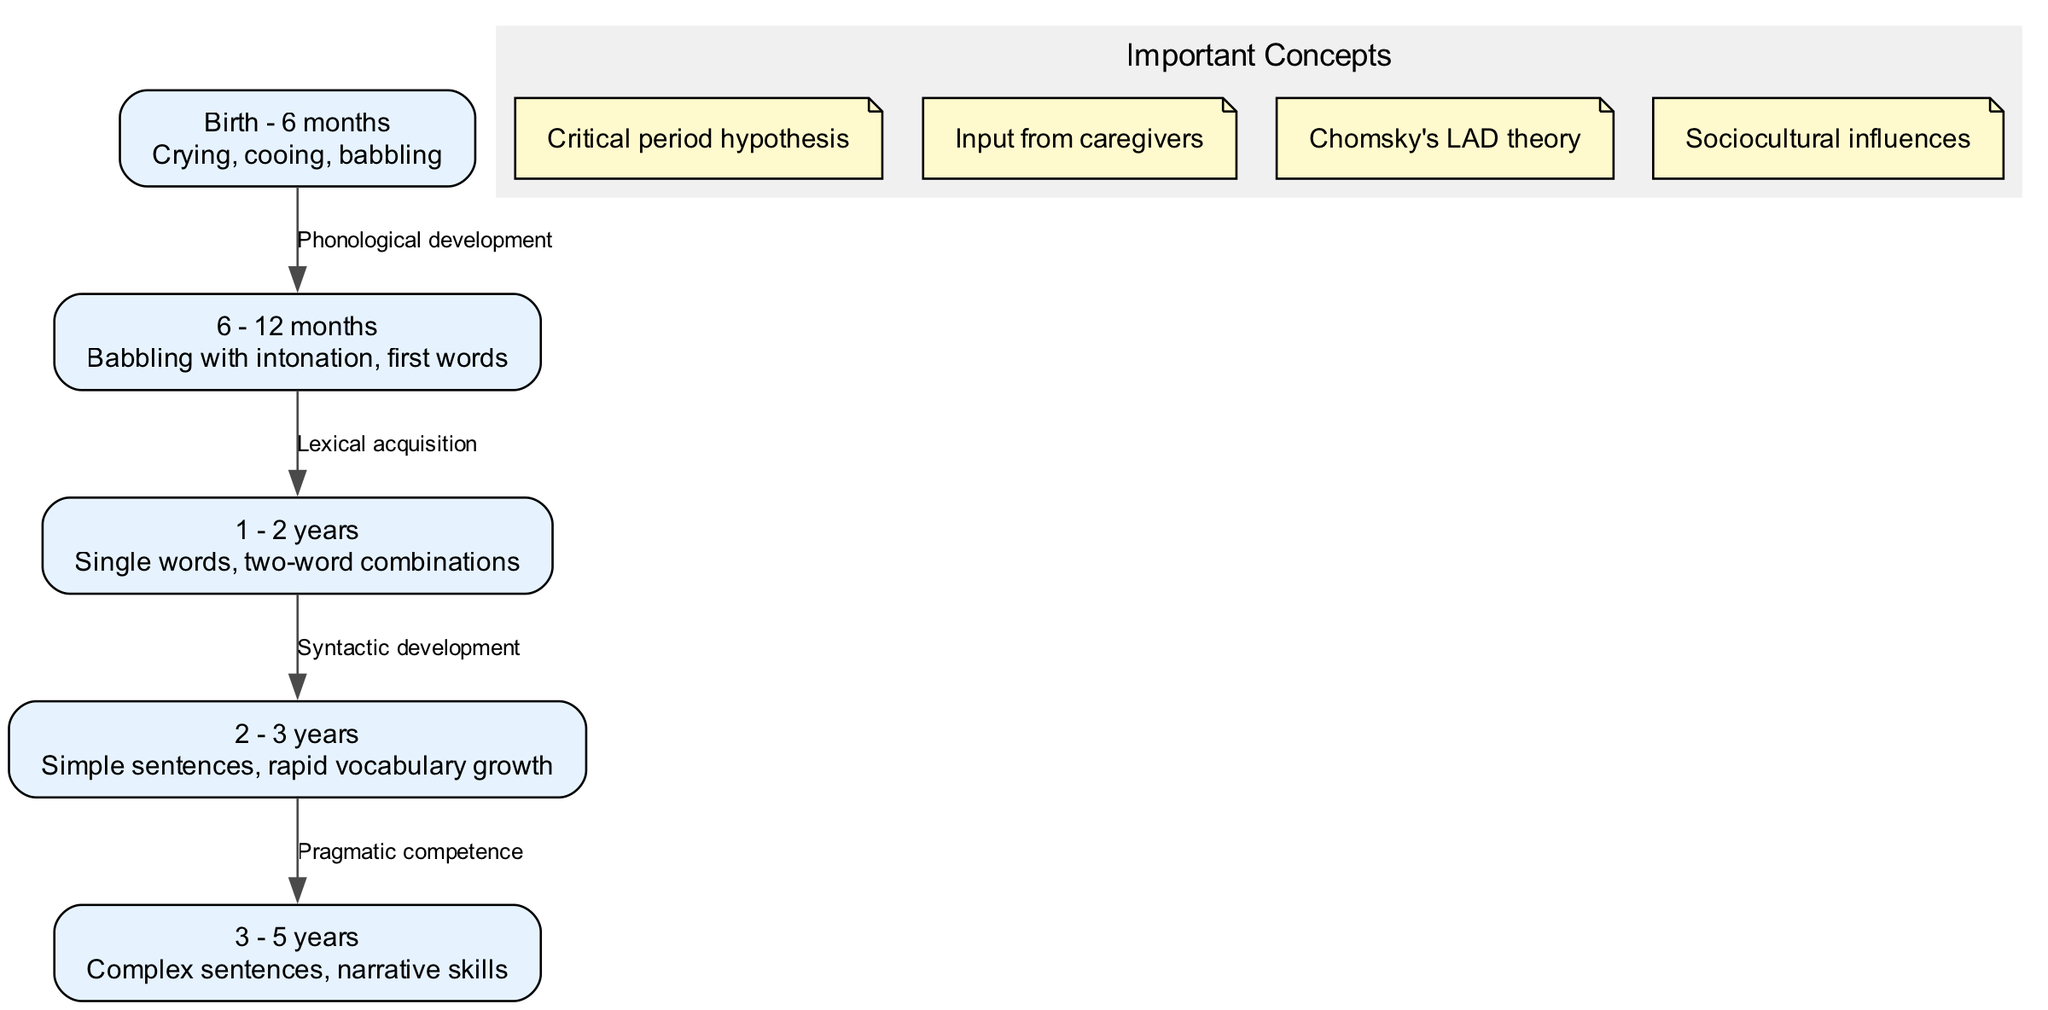What is the age range for the first node in the diagram? The first node is labeled "Birth - 6 months," indicating that this stage represents language acquisition from birth up to six months of age.
Answer: Birth - 6 months How many nodes are there in total? The diagram contains five nodes, each representing a different stage in language acquisition from birth to age five.
Answer: 5 What development is associated with the edge from node 1 to node 2? The edge connecting node 1 ("Birth - 6 months") to node 2 ("6 - 12 months") is labeled "Phonological development," indicating this is the type of development occurring during this transition.
Answer: Phonological development What is the description for the node at age 3-5 years? The node labeled "3 - 5 years" contains the description "Complex sentences, narrative skills," outlining the expected language ability by that age.
Answer: Complex sentences, narrative skills What type of competence is gained between the ages of 2 to 3 years? The edge from node 4 ("2 - 3 years") to node 5 ("3 - 5 years") is labeled "Pragmatic competence," showing the development of this language skill during that stage.
Answer: Pragmatic competence How does lexical acquisition relate to the language acquisition process? Lexical acquisition is specifically noted as the development occurring as children move from the stage of babbling with intonation (node 2) to the use of single words (node 3), showing a natural progression in language skills.
Answer: Lexical acquisition Which concept emphasizes the role of caregivers in language acquisition? The note stating "Input from caregivers" emphasizes that children learn language through interaction and exposure to spoken language from those around them.
Answer: Input from caregivers What age does rapid vocabulary growth occur according to the diagram? Rapid vocabulary growth is described in the node labeled "2 - 3 years," indicating this is the age range during which children's vocabulary expands significantly.
Answer: 2 - 3 years What kind of development is focused on in the transition from one to two years? The transition from one to two years is associated with "Syntactic development," indicating the children start to form basic grammatical structures.
Answer: Syntactic development 